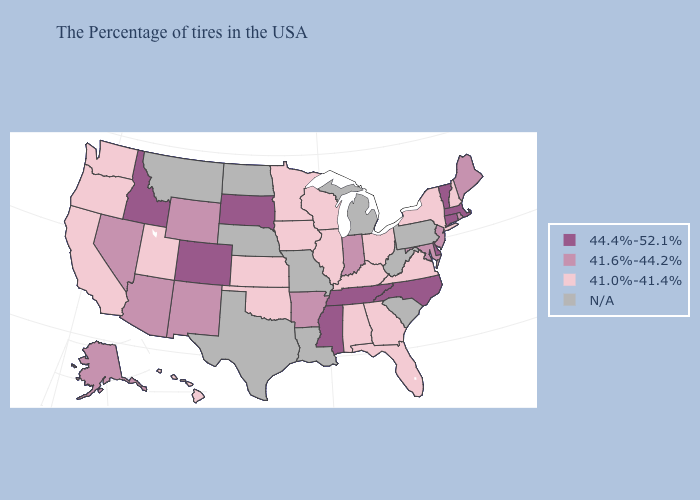Does Hawaii have the lowest value in the USA?
Be succinct. Yes. What is the highest value in the USA?
Answer briefly. 44.4%-52.1%. What is the highest value in states that border Utah?
Answer briefly. 44.4%-52.1%. Does Illinois have the highest value in the USA?
Keep it brief. No. What is the lowest value in the South?
Give a very brief answer. 41.0%-41.4%. Name the states that have a value in the range N/A?
Answer briefly. Pennsylvania, South Carolina, West Virginia, Michigan, Louisiana, Missouri, Nebraska, Texas, North Dakota, Montana. Among the states that border Tennessee , does Mississippi have the highest value?
Be succinct. Yes. Does Wyoming have the lowest value in the West?
Quick response, please. No. Among the states that border Vermont , which have the highest value?
Be succinct. Massachusetts. Among the states that border Washington , which have the lowest value?
Keep it brief. Oregon. Which states hav the highest value in the Northeast?
Keep it brief. Massachusetts, Vermont, Connecticut. Name the states that have a value in the range 41.0%-41.4%?
Concise answer only. New Hampshire, New York, Virginia, Ohio, Florida, Georgia, Kentucky, Alabama, Wisconsin, Illinois, Minnesota, Iowa, Kansas, Oklahoma, Utah, California, Washington, Oregon, Hawaii. Which states hav the highest value in the MidWest?
Short answer required. South Dakota. Does Idaho have the highest value in the USA?
Be succinct. Yes. What is the lowest value in the USA?
Quick response, please. 41.0%-41.4%. 